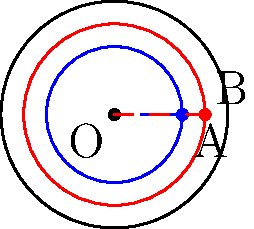In the Poincaré disk model of hyperbolic geometry shown above, two concentric circles (blue and red) are drawn within the unit disk. If the radii of these circles in the Euclidean plane are 0.6 and 0.8 respectively, what is the hyperbolic distance between points A and B? To solve this problem, we'll follow these steps:

1) In the Poincaré disk model, the hyperbolic distance $d$ between two points $z_1$ and $z_2$ is given by:

   $$d = 2 \tanh^{-1}\left|\frac{z_2-z_1}{1-\bar{z_1}z_2}\right|$$

2) In our case, $z_1 = 0.6$ (point A) and $z_2 = 0.8$ (point B) on the real axis.

3) Substituting these values:

   $$d = 2 \tanh^{-1}\left|\frac{0.8-0.6}{1-(0.6)(0.8)}\right|$$

4) Simplify:
   
   $$d = 2 \tanh^{-1}\left|\frac{0.2}{1-0.48}\right| = 2 \tanh^{-1}\left|\frac{0.2}{0.52}\right|$$

5) Calculate:

   $$d = 2 \tanh^{-1}(0.3846) \approx 0.8185$$

Therefore, the hyperbolic distance between points A and B is approximately 0.8185.
Answer: 0.8185 